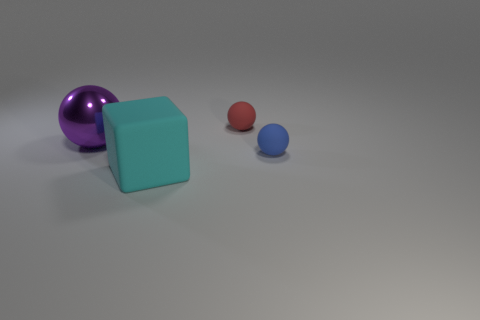Subtract all big balls. How many balls are left? 2 Add 2 tiny yellow matte things. How many objects exist? 6 Subtract all blue spheres. How many spheres are left? 2 Subtract all balls. How many objects are left? 1 Subtract all green balls. Subtract all red cylinders. How many balls are left? 3 Subtract all purple rubber cylinders. Subtract all tiny spheres. How many objects are left? 2 Add 3 cyan cubes. How many cyan cubes are left? 4 Add 3 small spheres. How many small spheres exist? 5 Subtract 0 green spheres. How many objects are left? 4 